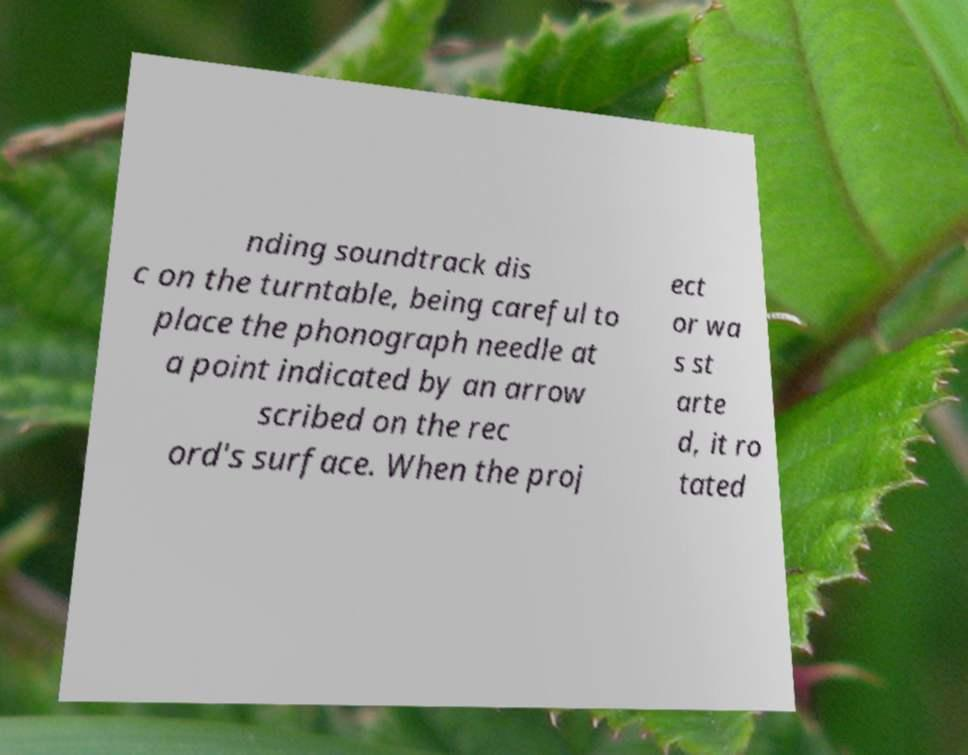Please read and relay the text visible in this image. What does it say? nding soundtrack dis c on the turntable, being careful to place the phonograph needle at a point indicated by an arrow scribed on the rec ord's surface. When the proj ect or wa s st arte d, it ro tated 